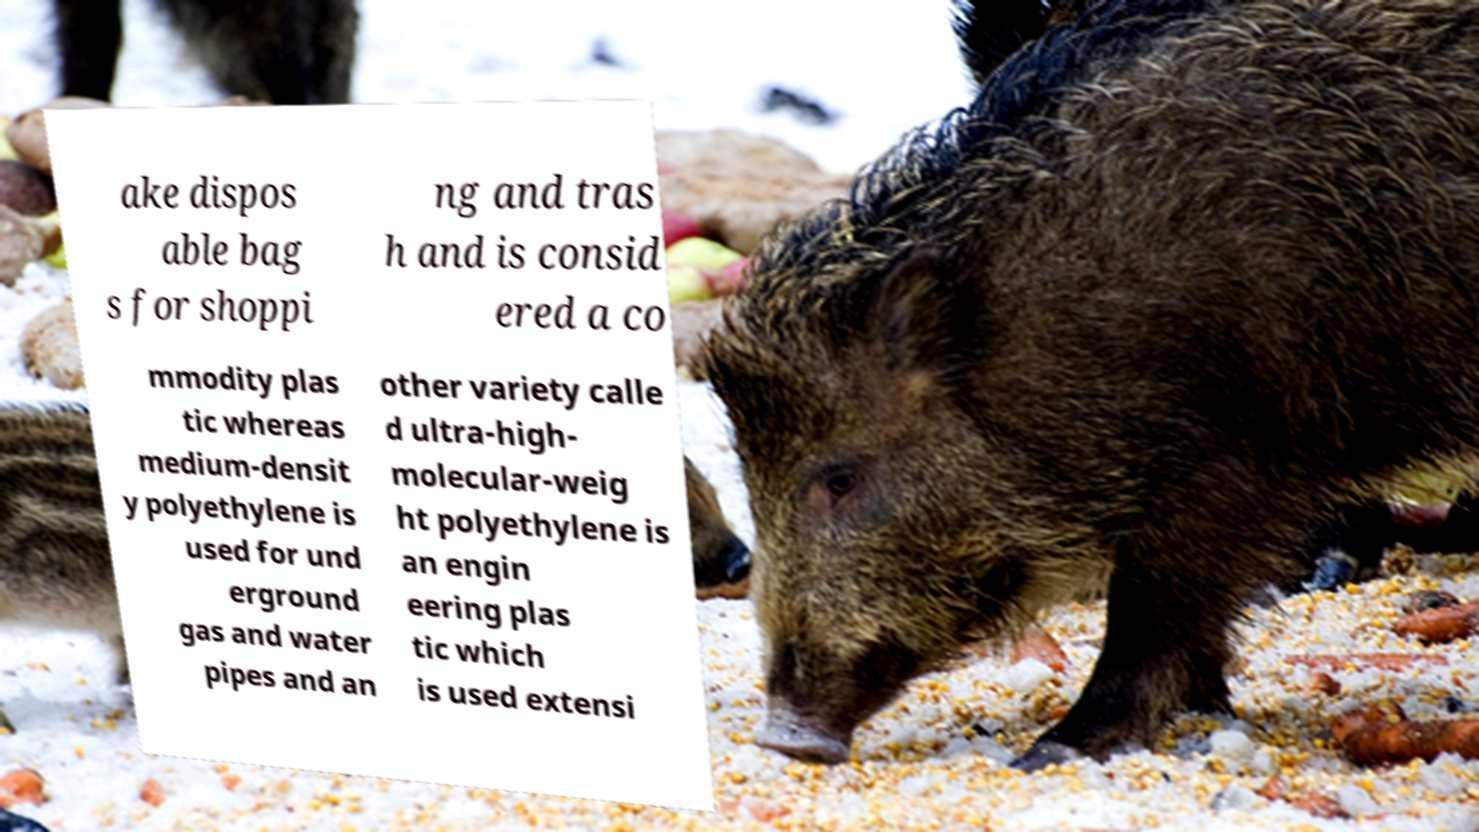Could you assist in decoding the text presented in this image and type it out clearly? ake dispos able bag s for shoppi ng and tras h and is consid ered a co mmodity plas tic whereas medium-densit y polyethylene is used for und erground gas and water pipes and an other variety calle d ultra-high- molecular-weig ht polyethylene is an engin eering plas tic which is used extensi 